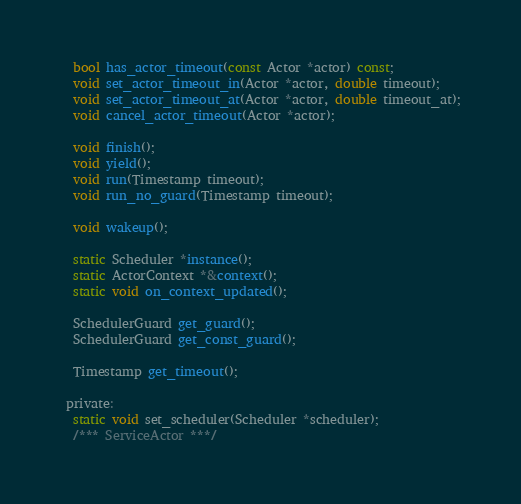Convert code to text. <code><loc_0><loc_0><loc_500><loc_500><_C_>  bool has_actor_timeout(const Actor *actor) const;
  void set_actor_timeout_in(Actor *actor, double timeout);
  void set_actor_timeout_at(Actor *actor, double timeout_at);
  void cancel_actor_timeout(Actor *actor);

  void finish();
  void yield();
  void run(Timestamp timeout);
  void run_no_guard(Timestamp timeout);

  void wakeup();

  static Scheduler *instance();
  static ActorContext *&context();
  static void on_context_updated();

  SchedulerGuard get_guard();
  SchedulerGuard get_const_guard();

  Timestamp get_timeout();

 private:
  static void set_scheduler(Scheduler *scheduler);
  /*** ServiceActor ***/</code> 